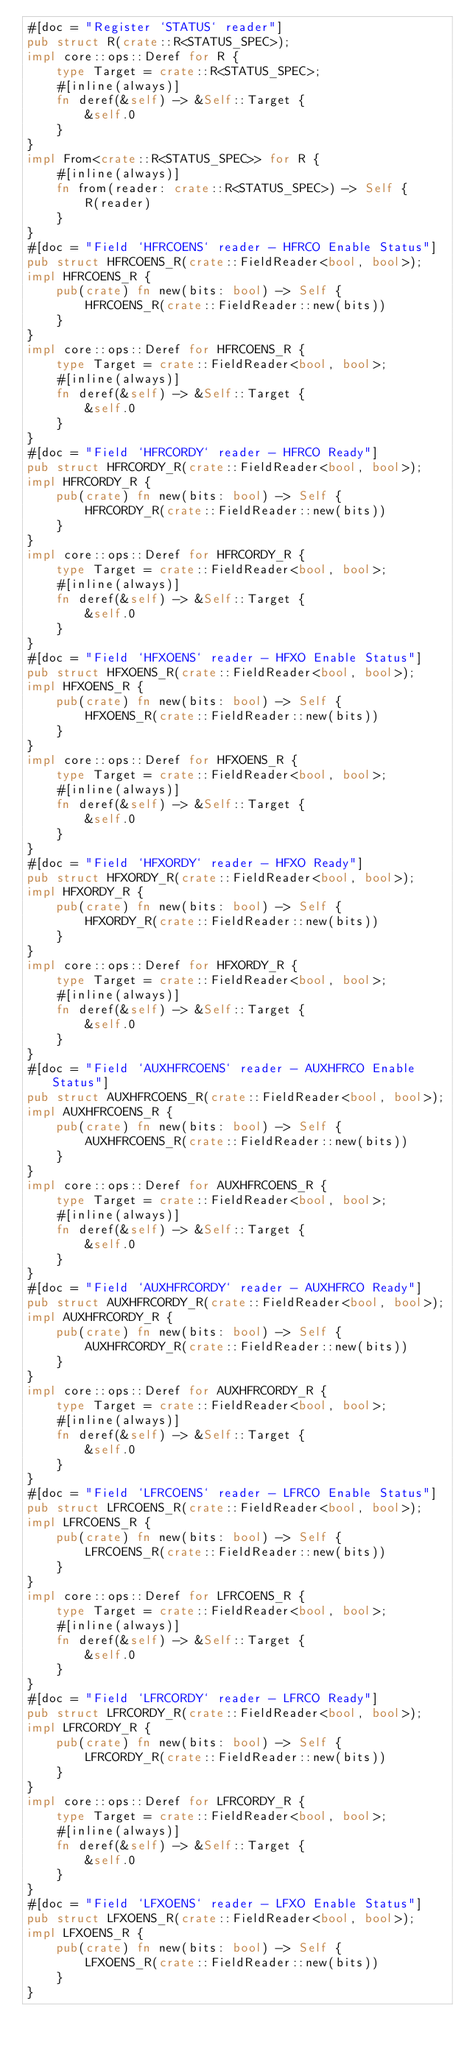Convert code to text. <code><loc_0><loc_0><loc_500><loc_500><_Rust_>#[doc = "Register `STATUS` reader"]
pub struct R(crate::R<STATUS_SPEC>);
impl core::ops::Deref for R {
    type Target = crate::R<STATUS_SPEC>;
    #[inline(always)]
    fn deref(&self) -> &Self::Target {
        &self.0
    }
}
impl From<crate::R<STATUS_SPEC>> for R {
    #[inline(always)]
    fn from(reader: crate::R<STATUS_SPEC>) -> Self {
        R(reader)
    }
}
#[doc = "Field `HFRCOENS` reader - HFRCO Enable Status"]
pub struct HFRCOENS_R(crate::FieldReader<bool, bool>);
impl HFRCOENS_R {
    pub(crate) fn new(bits: bool) -> Self {
        HFRCOENS_R(crate::FieldReader::new(bits))
    }
}
impl core::ops::Deref for HFRCOENS_R {
    type Target = crate::FieldReader<bool, bool>;
    #[inline(always)]
    fn deref(&self) -> &Self::Target {
        &self.0
    }
}
#[doc = "Field `HFRCORDY` reader - HFRCO Ready"]
pub struct HFRCORDY_R(crate::FieldReader<bool, bool>);
impl HFRCORDY_R {
    pub(crate) fn new(bits: bool) -> Self {
        HFRCORDY_R(crate::FieldReader::new(bits))
    }
}
impl core::ops::Deref for HFRCORDY_R {
    type Target = crate::FieldReader<bool, bool>;
    #[inline(always)]
    fn deref(&self) -> &Self::Target {
        &self.0
    }
}
#[doc = "Field `HFXOENS` reader - HFXO Enable Status"]
pub struct HFXOENS_R(crate::FieldReader<bool, bool>);
impl HFXOENS_R {
    pub(crate) fn new(bits: bool) -> Self {
        HFXOENS_R(crate::FieldReader::new(bits))
    }
}
impl core::ops::Deref for HFXOENS_R {
    type Target = crate::FieldReader<bool, bool>;
    #[inline(always)]
    fn deref(&self) -> &Self::Target {
        &self.0
    }
}
#[doc = "Field `HFXORDY` reader - HFXO Ready"]
pub struct HFXORDY_R(crate::FieldReader<bool, bool>);
impl HFXORDY_R {
    pub(crate) fn new(bits: bool) -> Self {
        HFXORDY_R(crate::FieldReader::new(bits))
    }
}
impl core::ops::Deref for HFXORDY_R {
    type Target = crate::FieldReader<bool, bool>;
    #[inline(always)]
    fn deref(&self) -> &Self::Target {
        &self.0
    }
}
#[doc = "Field `AUXHFRCOENS` reader - AUXHFRCO Enable Status"]
pub struct AUXHFRCOENS_R(crate::FieldReader<bool, bool>);
impl AUXHFRCOENS_R {
    pub(crate) fn new(bits: bool) -> Self {
        AUXHFRCOENS_R(crate::FieldReader::new(bits))
    }
}
impl core::ops::Deref for AUXHFRCOENS_R {
    type Target = crate::FieldReader<bool, bool>;
    #[inline(always)]
    fn deref(&self) -> &Self::Target {
        &self.0
    }
}
#[doc = "Field `AUXHFRCORDY` reader - AUXHFRCO Ready"]
pub struct AUXHFRCORDY_R(crate::FieldReader<bool, bool>);
impl AUXHFRCORDY_R {
    pub(crate) fn new(bits: bool) -> Self {
        AUXHFRCORDY_R(crate::FieldReader::new(bits))
    }
}
impl core::ops::Deref for AUXHFRCORDY_R {
    type Target = crate::FieldReader<bool, bool>;
    #[inline(always)]
    fn deref(&self) -> &Self::Target {
        &self.0
    }
}
#[doc = "Field `LFRCOENS` reader - LFRCO Enable Status"]
pub struct LFRCOENS_R(crate::FieldReader<bool, bool>);
impl LFRCOENS_R {
    pub(crate) fn new(bits: bool) -> Self {
        LFRCOENS_R(crate::FieldReader::new(bits))
    }
}
impl core::ops::Deref for LFRCOENS_R {
    type Target = crate::FieldReader<bool, bool>;
    #[inline(always)]
    fn deref(&self) -> &Self::Target {
        &self.0
    }
}
#[doc = "Field `LFRCORDY` reader - LFRCO Ready"]
pub struct LFRCORDY_R(crate::FieldReader<bool, bool>);
impl LFRCORDY_R {
    pub(crate) fn new(bits: bool) -> Self {
        LFRCORDY_R(crate::FieldReader::new(bits))
    }
}
impl core::ops::Deref for LFRCORDY_R {
    type Target = crate::FieldReader<bool, bool>;
    #[inline(always)]
    fn deref(&self) -> &Self::Target {
        &self.0
    }
}
#[doc = "Field `LFXOENS` reader - LFXO Enable Status"]
pub struct LFXOENS_R(crate::FieldReader<bool, bool>);
impl LFXOENS_R {
    pub(crate) fn new(bits: bool) -> Self {
        LFXOENS_R(crate::FieldReader::new(bits))
    }
}</code> 